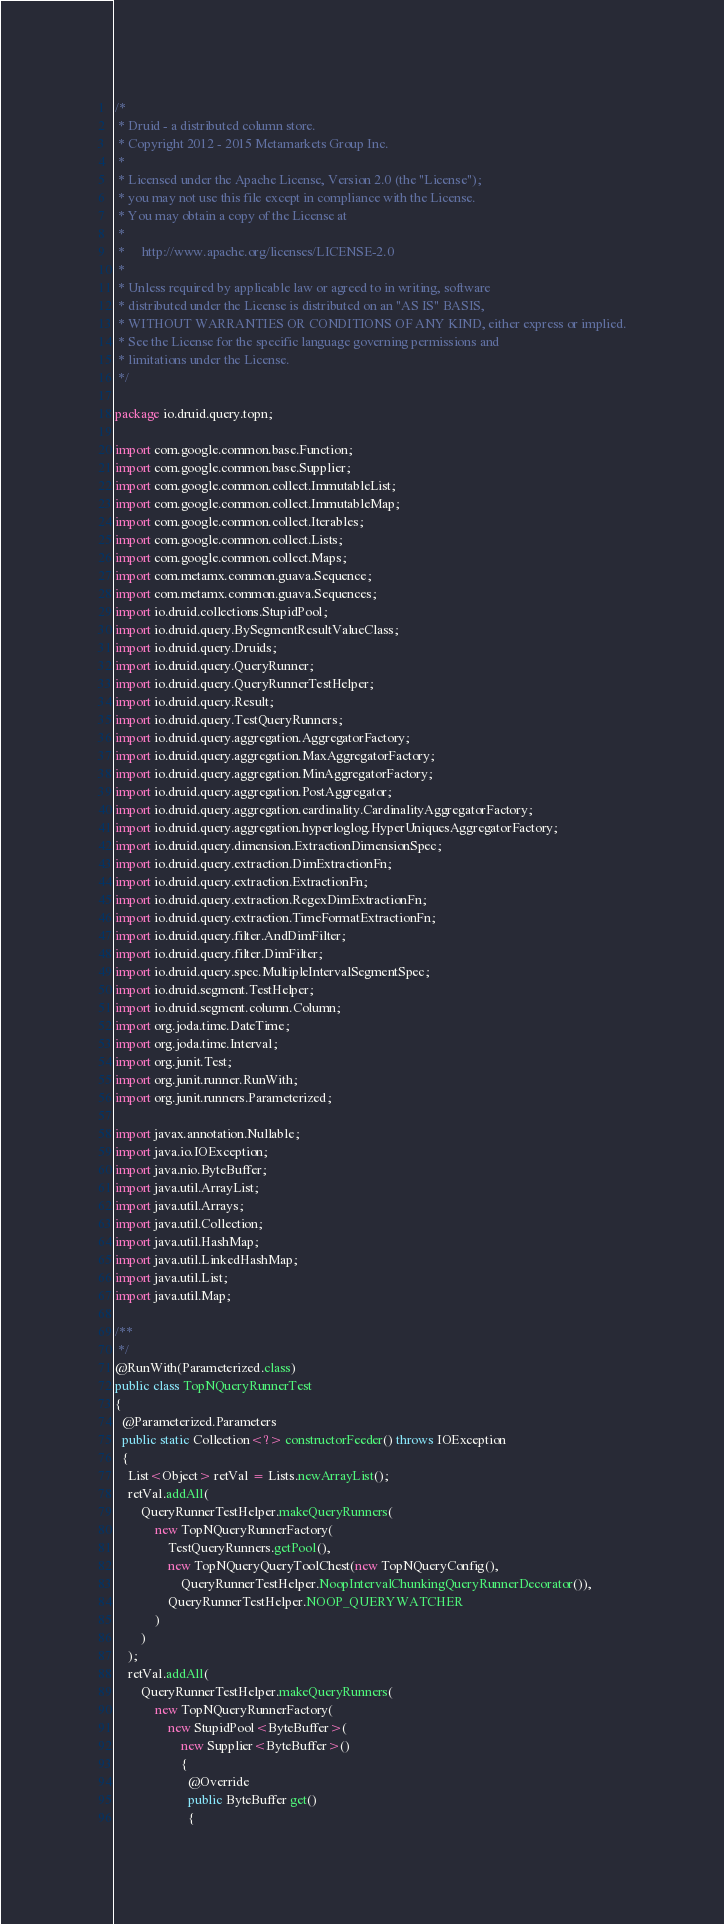Convert code to text. <code><loc_0><loc_0><loc_500><loc_500><_Java_>/*
 * Druid - a distributed column store.
 * Copyright 2012 - 2015 Metamarkets Group Inc.
 *
 * Licensed under the Apache License, Version 2.0 (the "License");
 * you may not use this file except in compliance with the License.
 * You may obtain a copy of the License at
 *
 *     http://www.apache.org/licenses/LICENSE-2.0
 *
 * Unless required by applicable law or agreed to in writing, software
 * distributed under the License is distributed on an "AS IS" BASIS,
 * WITHOUT WARRANTIES OR CONDITIONS OF ANY KIND, either express or implied.
 * See the License for the specific language governing permissions and
 * limitations under the License.
 */

package io.druid.query.topn;

import com.google.common.base.Function;
import com.google.common.base.Supplier;
import com.google.common.collect.ImmutableList;
import com.google.common.collect.ImmutableMap;
import com.google.common.collect.Iterables;
import com.google.common.collect.Lists;
import com.google.common.collect.Maps;
import com.metamx.common.guava.Sequence;
import com.metamx.common.guava.Sequences;
import io.druid.collections.StupidPool;
import io.druid.query.BySegmentResultValueClass;
import io.druid.query.Druids;
import io.druid.query.QueryRunner;
import io.druid.query.QueryRunnerTestHelper;
import io.druid.query.Result;
import io.druid.query.TestQueryRunners;
import io.druid.query.aggregation.AggregatorFactory;
import io.druid.query.aggregation.MaxAggregatorFactory;
import io.druid.query.aggregation.MinAggregatorFactory;
import io.druid.query.aggregation.PostAggregator;
import io.druid.query.aggregation.cardinality.CardinalityAggregatorFactory;
import io.druid.query.aggregation.hyperloglog.HyperUniquesAggregatorFactory;
import io.druid.query.dimension.ExtractionDimensionSpec;
import io.druid.query.extraction.DimExtractionFn;
import io.druid.query.extraction.ExtractionFn;
import io.druid.query.extraction.RegexDimExtractionFn;
import io.druid.query.extraction.TimeFormatExtractionFn;
import io.druid.query.filter.AndDimFilter;
import io.druid.query.filter.DimFilter;
import io.druid.query.spec.MultipleIntervalSegmentSpec;
import io.druid.segment.TestHelper;
import io.druid.segment.column.Column;
import org.joda.time.DateTime;
import org.joda.time.Interval;
import org.junit.Test;
import org.junit.runner.RunWith;
import org.junit.runners.Parameterized;

import javax.annotation.Nullable;
import java.io.IOException;
import java.nio.ByteBuffer;
import java.util.ArrayList;
import java.util.Arrays;
import java.util.Collection;
import java.util.HashMap;
import java.util.LinkedHashMap;
import java.util.List;
import java.util.Map;

/**
 */
@RunWith(Parameterized.class)
public class TopNQueryRunnerTest
{
  @Parameterized.Parameters
  public static Collection<?> constructorFeeder() throws IOException
  {
    List<Object> retVal = Lists.newArrayList();
    retVal.addAll(
        QueryRunnerTestHelper.makeQueryRunners(
            new TopNQueryRunnerFactory(
                TestQueryRunners.getPool(),
                new TopNQueryQueryToolChest(new TopNQueryConfig(),
                    QueryRunnerTestHelper.NoopIntervalChunkingQueryRunnerDecorator()),
                QueryRunnerTestHelper.NOOP_QUERYWATCHER
            )
        )
    );
    retVal.addAll(
        QueryRunnerTestHelper.makeQueryRunners(
            new TopNQueryRunnerFactory(
                new StupidPool<ByteBuffer>(
                    new Supplier<ByteBuffer>()
                    {
                      @Override
                      public ByteBuffer get()
                      {</code> 